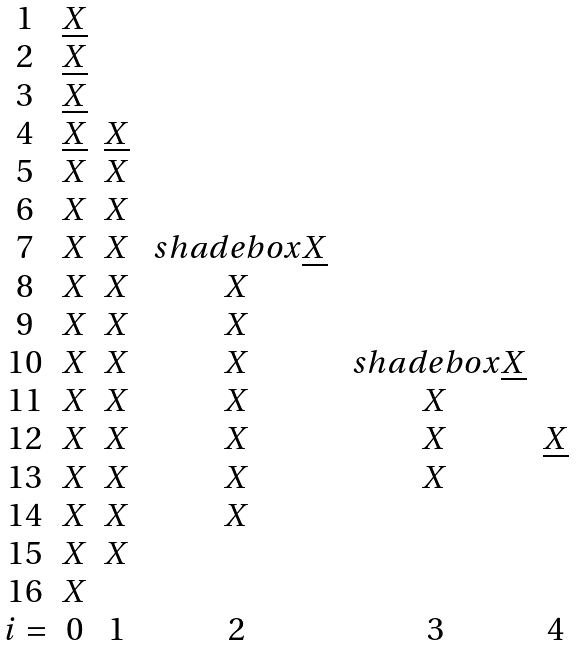Convert formula to latex. <formula><loc_0><loc_0><loc_500><loc_500>\begin{matrix} 1 & \underline { X } & & & & \\ 2 & \underline { X } & & & & \\ 3 & \underline { X } & & & & \\ 4 & \underline { X } & \underline { X } & & & \\ 5 & X & X & & & \\ 6 & X & X & & & \\ 7 & X & X & \ s h a d e b o x { \underline { X } } & & \\ 8 & X & X & X & & \\ 9 & X & X & X & & \\ 1 0 & X & X & X & \ s h a d e b o x { \underline { X } } & \\ 1 1 & X & X & X & X & \\ 1 2 & X & X & X & X & \underline { X } \\ 1 3 & X & X & X & X & \\ 1 4 & X & X & X & & \\ 1 5 & X & X & & & \\ 1 6 & X & & & & \\ i = & 0 & 1 & 2 & 3 & 4 \end{matrix}</formula> 